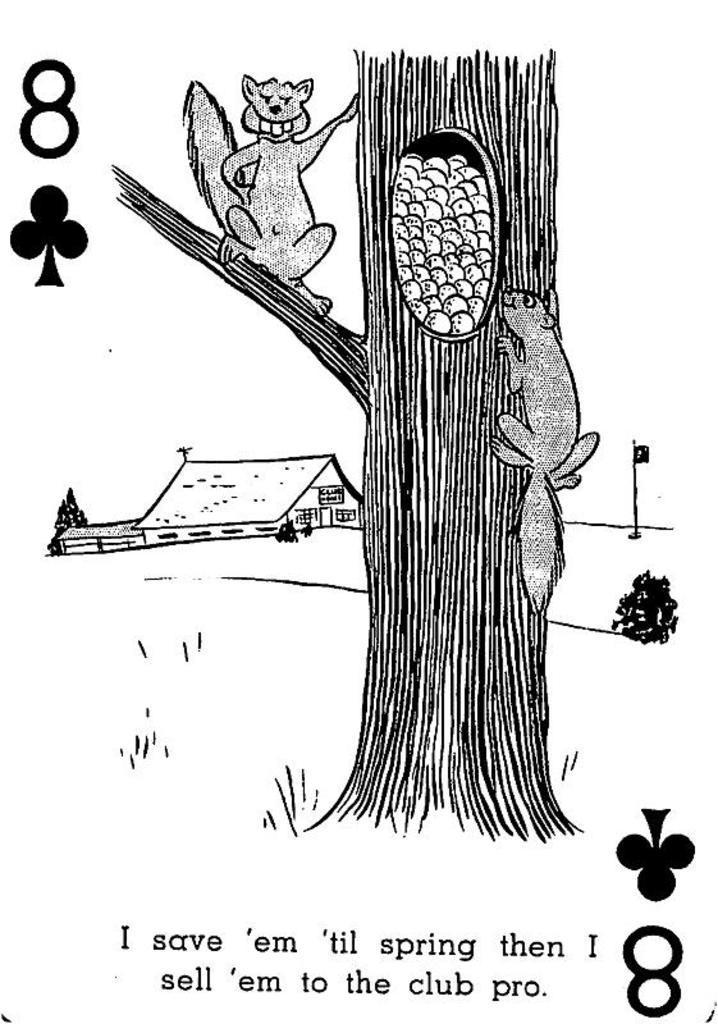How would you summarize this image in a sentence or two? The picture is a drawing. At the bottom we can see text, number and a symbol. In the center of the picture we can see squirrels, tree and other objects. At the top towards left there are number and symbol. On the left there is a house and tree. On the right we can see a plant and flag. 